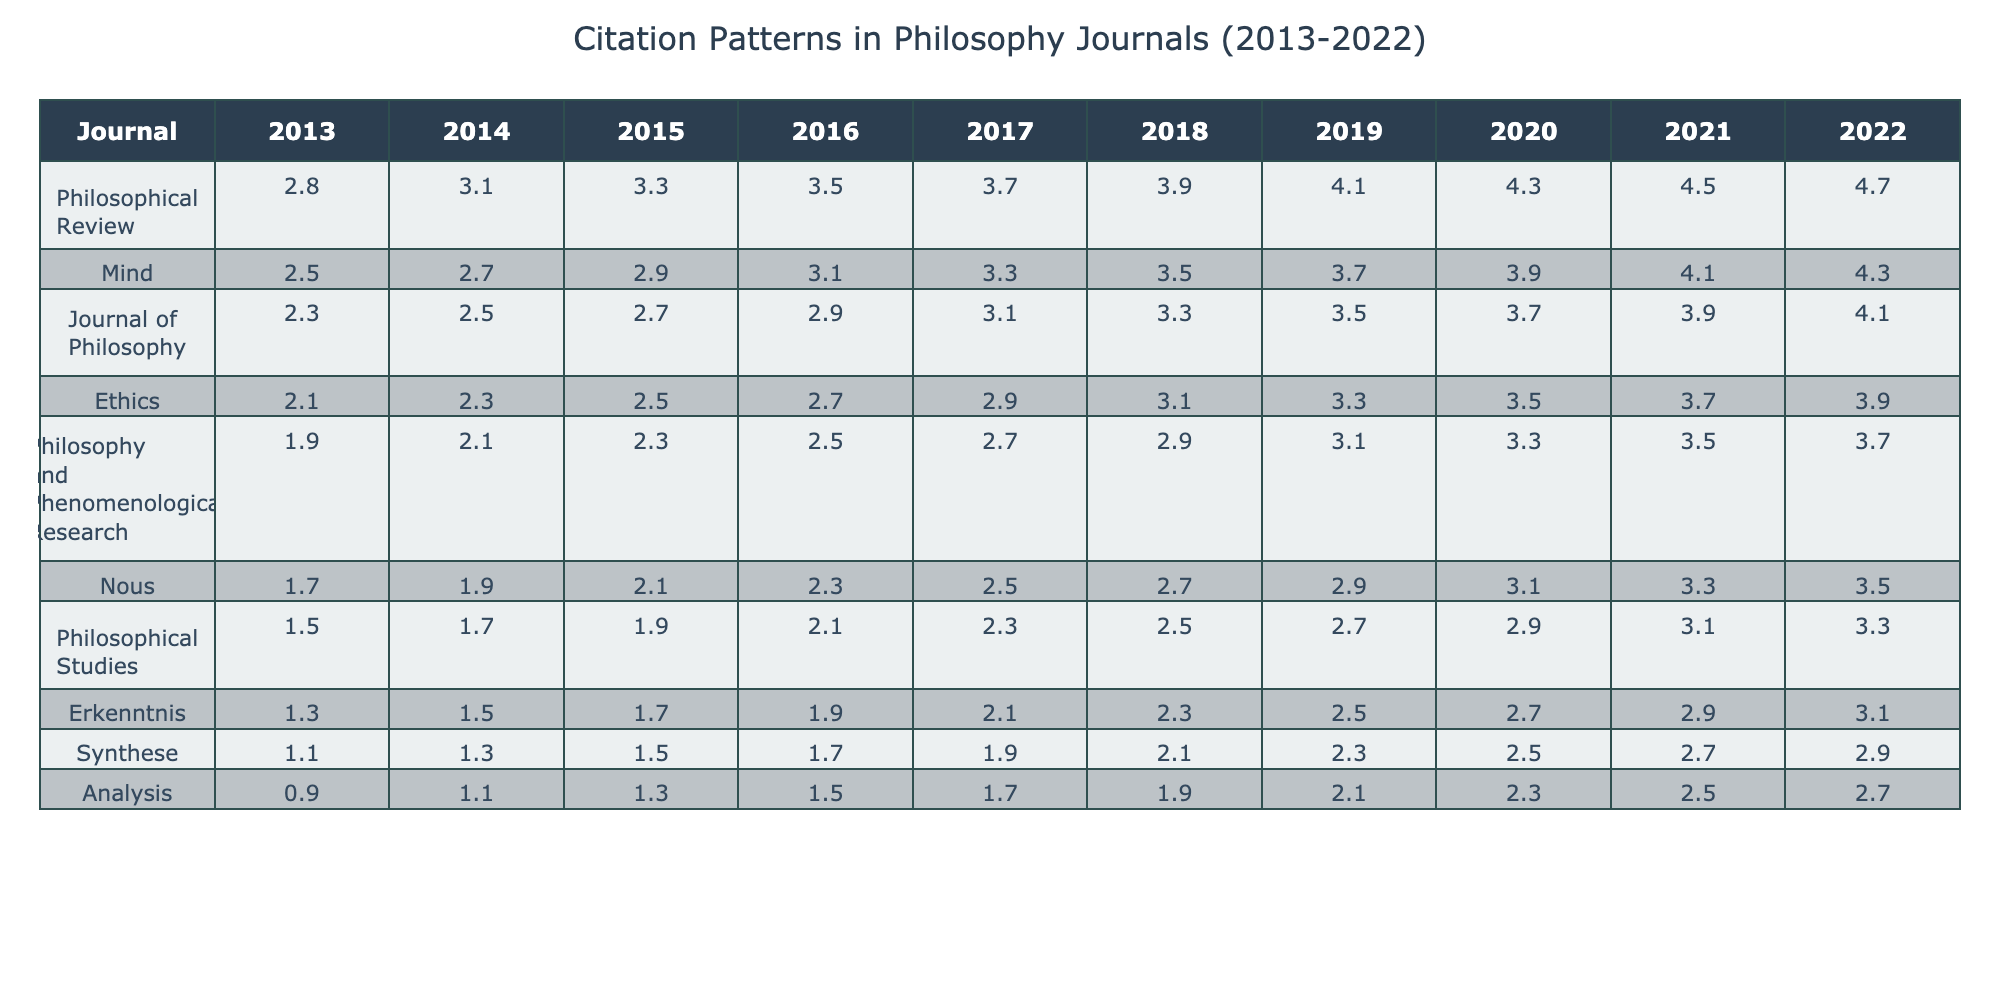What was the citation score for the Philosophical Review in 2019? The citation score for the Philosophical Review in 2019 is listed as 4.1 in the corresponding cell of the table.
Answer: 4.1 Which journal had the lowest citation score in 2013? Upon examining the table, the journal with the lowest citation score in 2013 is Synthese, which has a score of 1.1.
Answer: Synthese What is the average citation score for the journal Mind across the years 2018 to 2022? The citation scores for Mind from 2018 to 2022 are 3.5, 3.7, 3.9, 4.1, and 4.3. Summing these scores results in 3.5 + 3.7 + 3.9 + 4.1 + 4.3 = 19.5. Dividing by 5 gives an average of 19.5 / 5 = 3.9.
Answer: 3.9 Did the journal Nous increase its citation score every year from 2014 to 2022? Reviewing the table, Nous shows an increase in citation scores from 1.9 in 2014 to 3.5 in 2022, thus confirming it increased each year during this period.
Answer: Yes Which journal showed the most significant increase in citation score from 2013 to 2022, and what was the total increase? By comparing the scores for each journal in 2013 and 2022, Philosophical Review has a score of 2.8 in 2013 and 4.7 in 2022. The total increase for this journal is 4.7 - 2.8 = 1.9. The next highest increase can be calculated for Journal of Philosophy, which is 4.1 - 2.3 = 1.8, thus the Philosophical Review has the most significant increase.
Answer: Philosophical Review, 1.9 What was the median citation score for all journals in 2021? The citation scores for all journals in 2021 are 4.5, 4.1, 3.9, 3.7, 3.5, 3.3, 3.1, 2.9, 2.7, and 2.5. When arranged in ascending order, the middle values are 3.3 and 3.5, which average to (3.3 + 3.5) / 2 = 3.4.
Answer: 3.4 Which journal demonstrates the highest value in 2020, and what is that value? In 2020, the journal with the highest citation score is Philosophical Review, which shows a score of 4.3, making it the highest for that year.
Answer: Philosophical Review, 4.3 